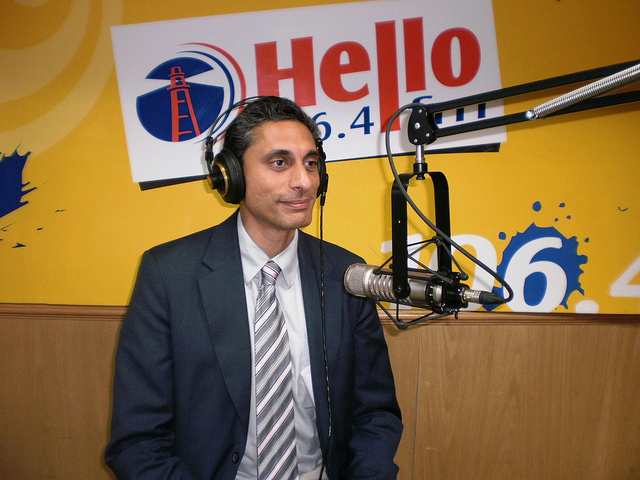Please extract the text content from this image. Hello fm 6.4 6 